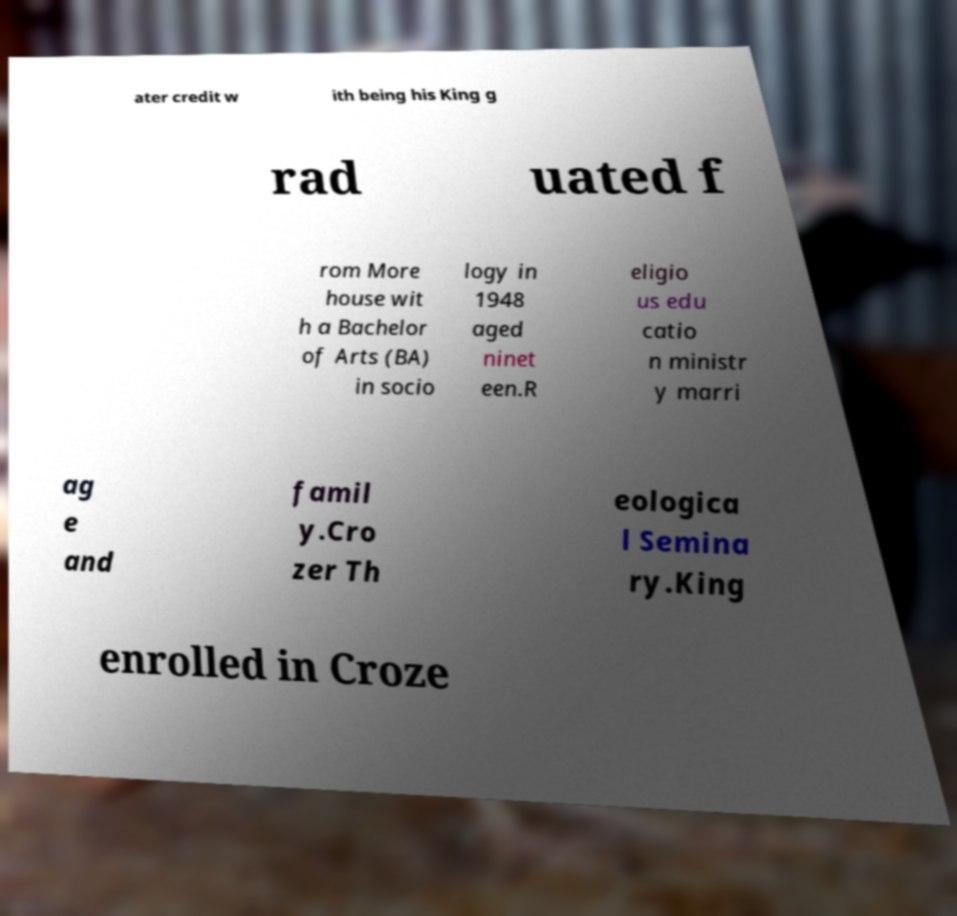Could you assist in decoding the text presented in this image and type it out clearly? ater credit w ith being his King g rad uated f rom More house wit h a Bachelor of Arts (BA) in socio logy in 1948 aged ninet een.R eligio us edu catio n ministr y marri ag e and famil y.Cro zer Th eologica l Semina ry.King enrolled in Croze 